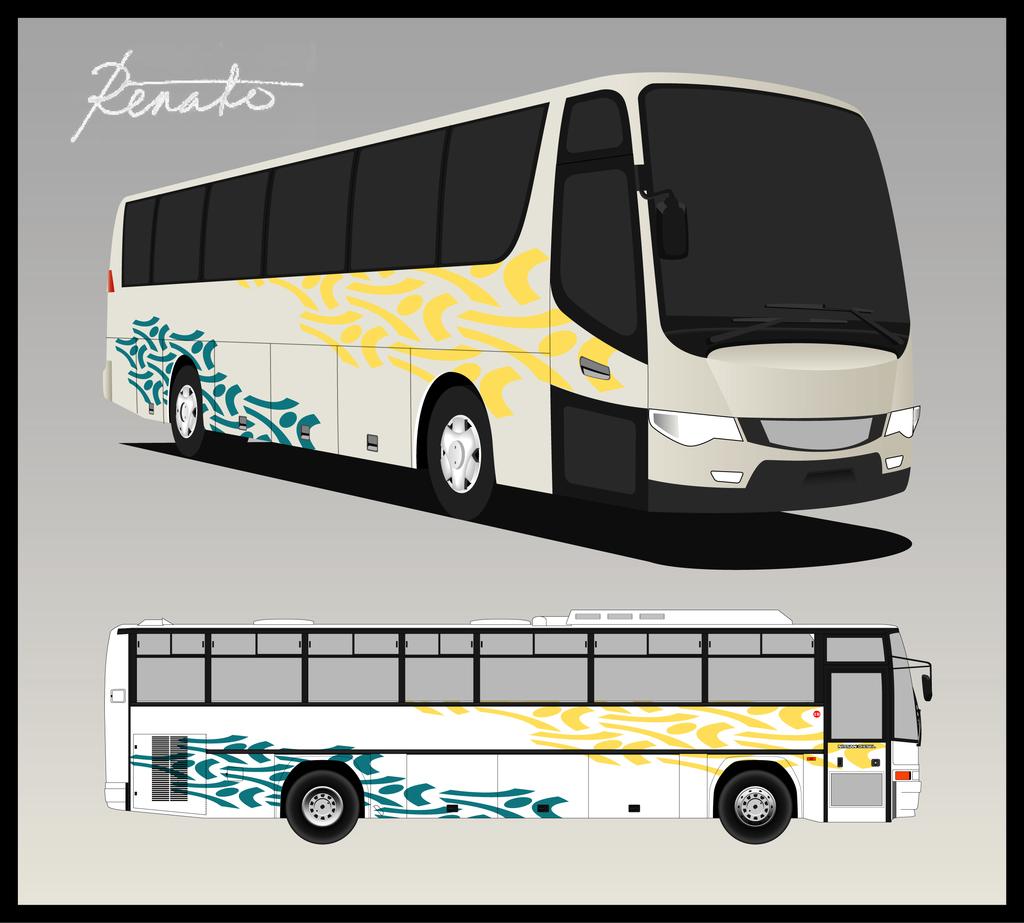Is the bus designer called "renato?"?
Keep it short and to the point. Yes. 